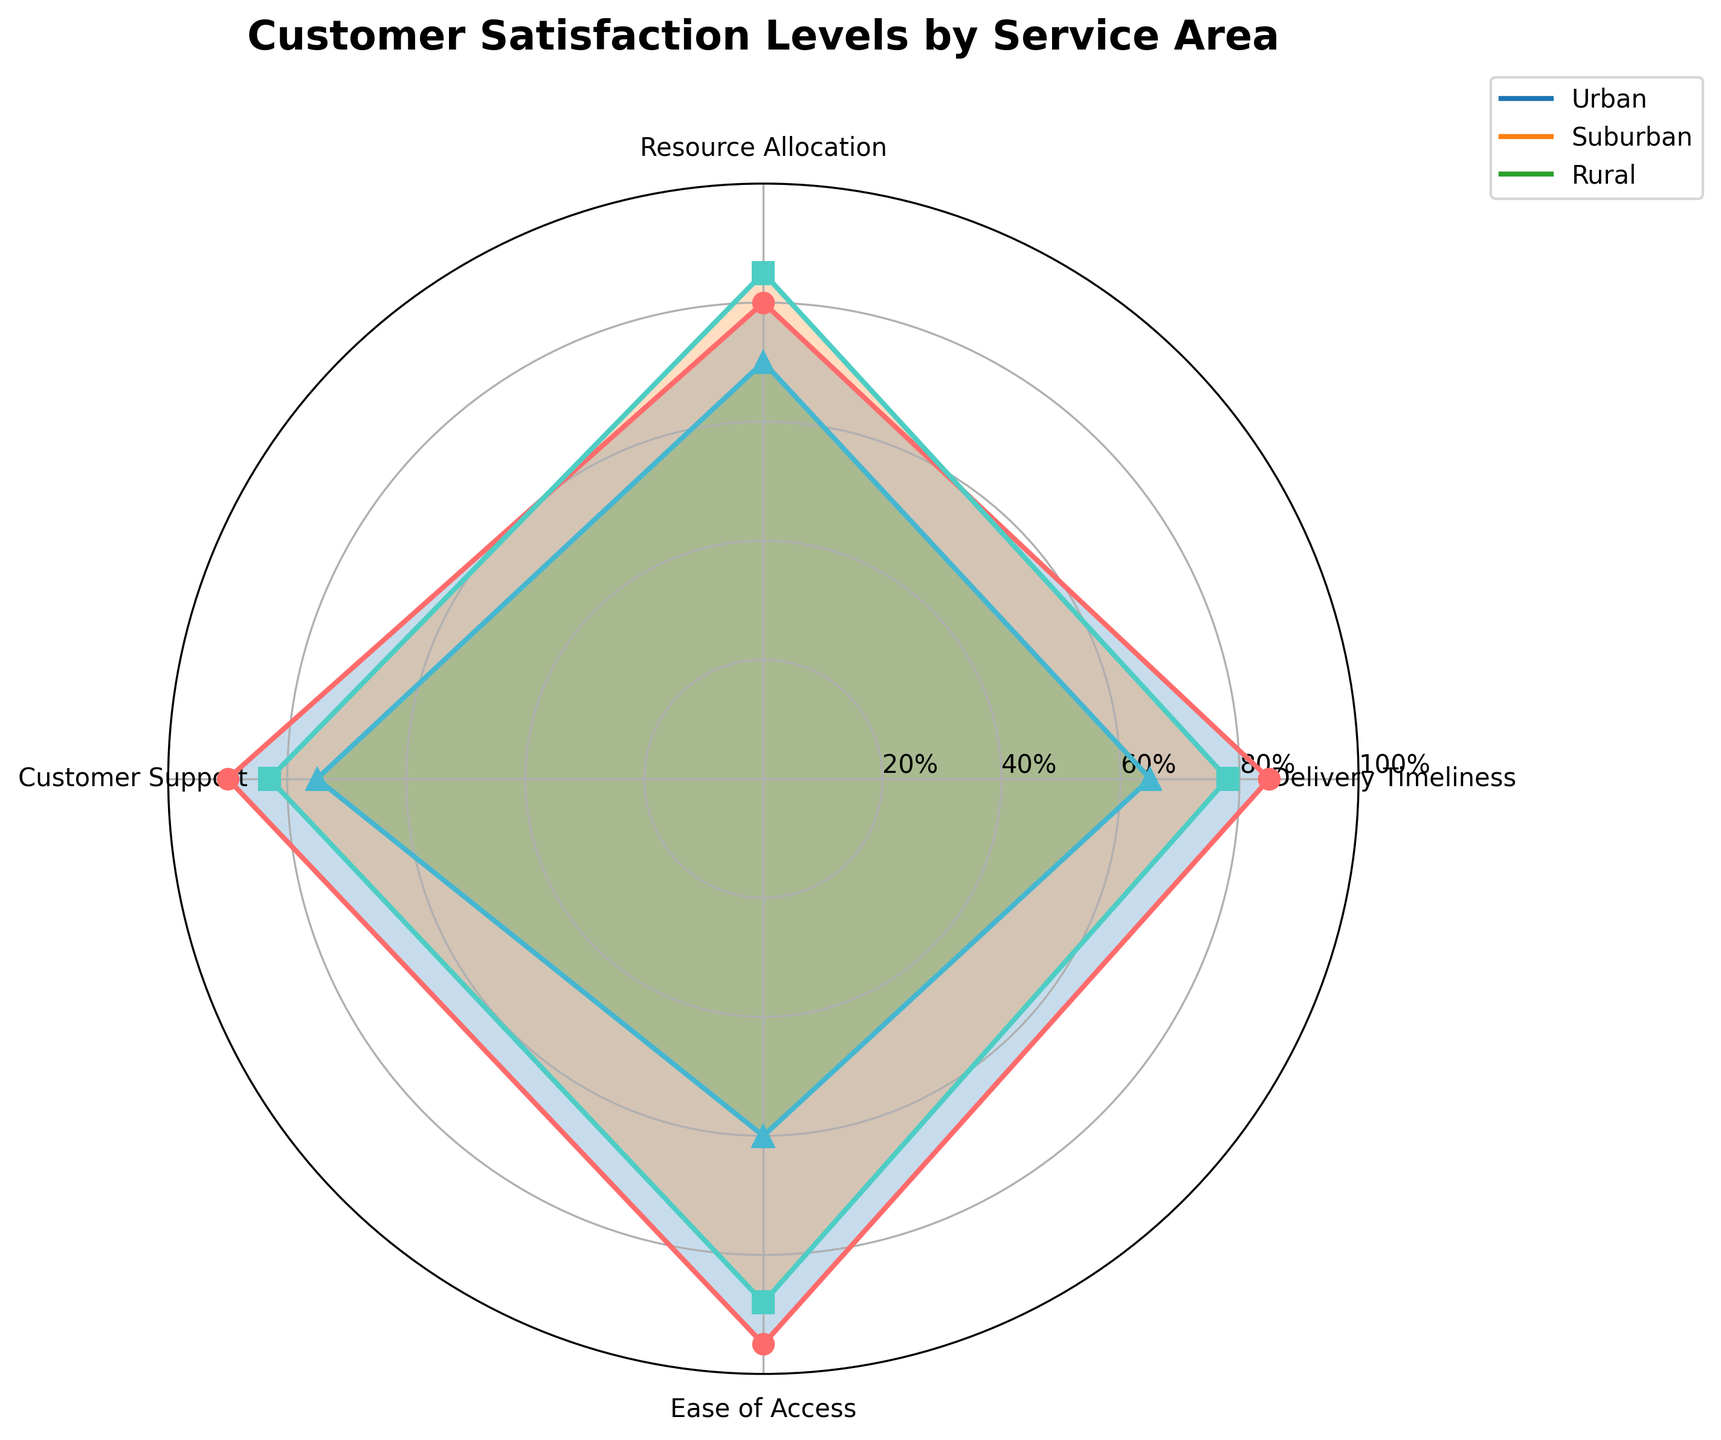What is the title of the figure? The title of the figure is usually found at the top. Here, it is "Customer Satisfaction Levels by Service Area".
Answer: Customer Satisfaction Levels by Service Area Which service area shows the highest value for Delivery Timeliness? To answer this, locate the Delivery Timeliness category on the radar chart and compare the values for Urban, Suburban, and Rural areas. Urban shows the highest value.
Answer: Urban How many categories are analyzed in this radar chart? Count the different segments or labels around the radar chart. There are 4 categories labeled Delivery Timeliness, Resource Allocation, Customer Support, and Ease of Access.
Answer: 4 Which service area has the lowest customer support rating, and what is the value? Identify the Customer Support category on the radar chart and find the lowest value among the service areas. Rural has the lowest value at 75.
Answer: Rural, 75 What is the average rating for Resource Allocation across all service areas? Add up the Resource Allocation values for Urban (80), Suburban (85), and Rural (70), and then divide by 3. (80 + 85 + 70) / 3 = 78.33
Answer: 78.33 Which category shows the most significant difference between Urban and Rural service areas? For each category, subtract the Rural value from the Urban value: Delivery Timeliness (85-65=20), Resource Allocation (80-70=10), Customer Support (90-75=15), Ease of Access (95-60=35). The largest difference is in Ease of Access.
Answer: Ease of Access Compare the overall performance in terms of average customer satisfaction between Urban and Rural areas. First, calculate the average for Urban: (85+80+90+95) / 4 = 87.5. Then calculate the average for Rural: (65+70+75+60) / 4 = 67.5. Urban has a higher average satisfaction.
Answer: Urban In which category do Suburban areas outperform Urban areas? Compare the values for each category between Suburban and Urban. Resource Allocation shows Suburban (85) is higher than Urban (80).
Answer: Resource Allocation Which service area has the most balanced performance across all categories? Look for the service area with the least variation among categories. Suburban values (78, 85, 83, 88) are relatively close to each other compared to Urban and Rural values.
Answer: Suburban 